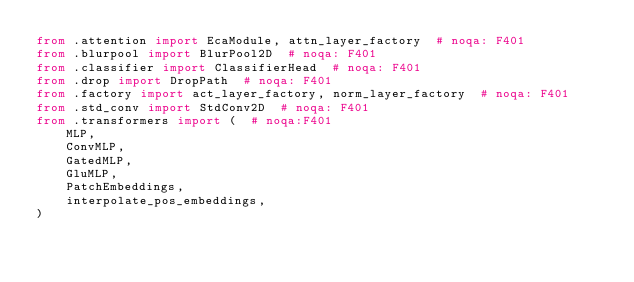Convert code to text. <code><loc_0><loc_0><loc_500><loc_500><_Python_>from .attention import EcaModule, attn_layer_factory  # noqa: F401
from .blurpool import BlurPool2D  # noqa: F401
from .classifier import ClassifierHead  # noqa: F401
from .drop import DropPath  # noqa: F401
from .factory import act_layer_factory, norm_layer_factory  # noqa: F401
from .std_conv import StdConv2D  # noqa: F401
from .transformers import (  # noqa:F401
    MLP,
    ConvMLP,
    GatedMLP,
    GluMLP,
    PatchEmbeddings,
    interpolate_pos_embeddings,
)
</code> 